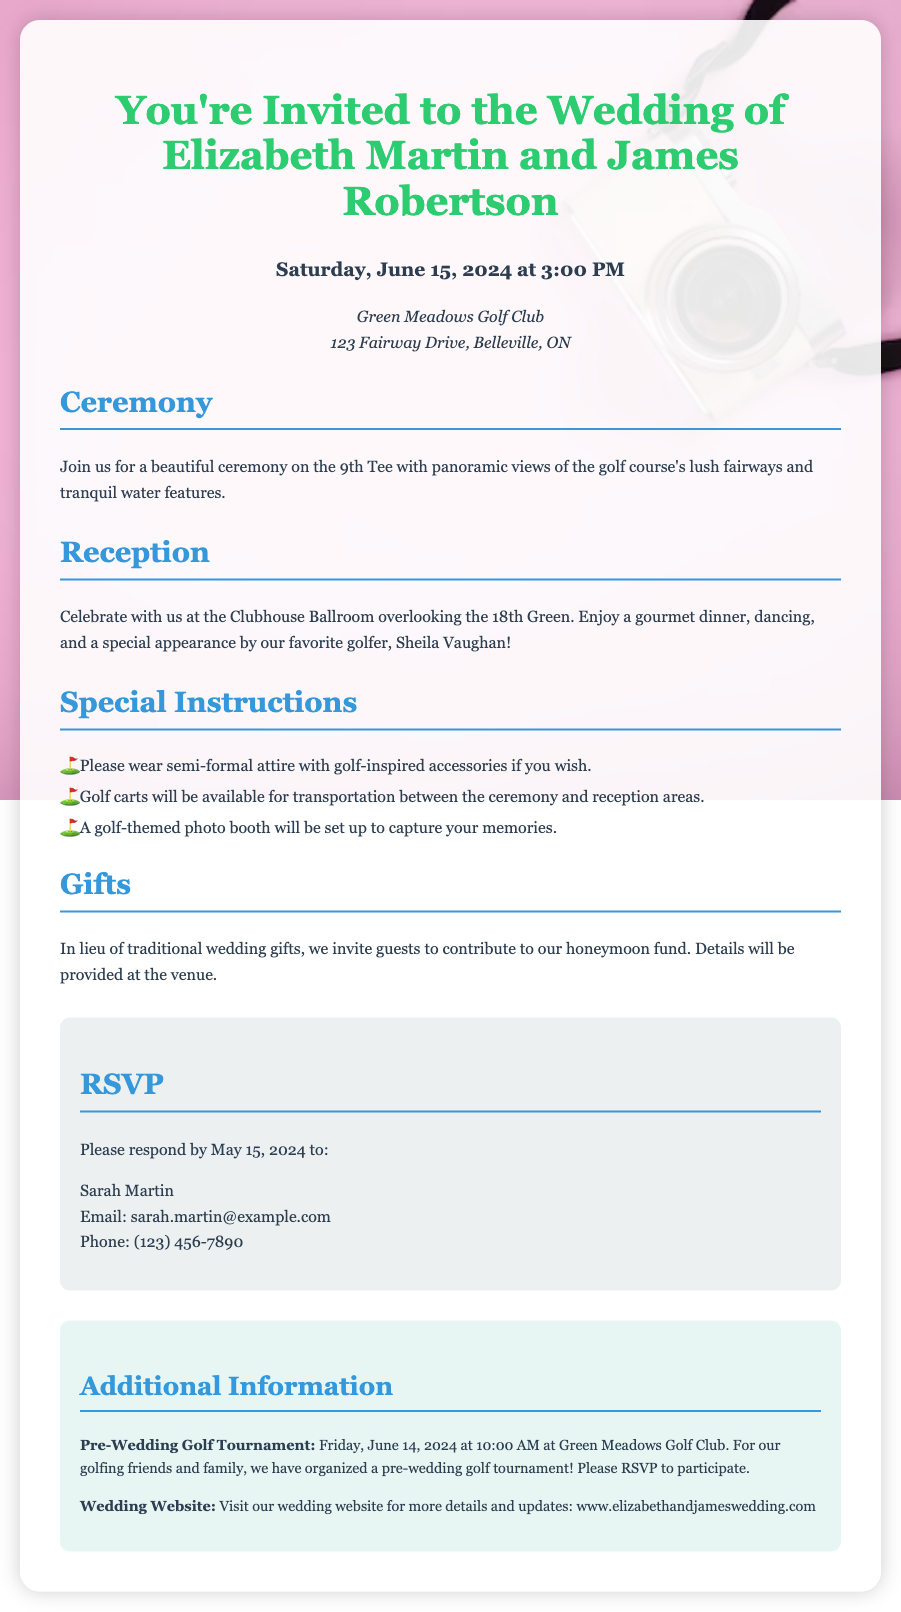What are the names of the couple? The names are stated prominently at the top of the invitation.
Answer: Elizabeth Martin and James Robertson When is the wedding date? The date is specified in the invitation under the date and time section.
Answer: Saturday, June 15, 2024 Where is the ceremony taking place? The location for the ceremony is mentioned in the venue section.
Answer: 9th Tee at Green Meadows Golf Club What type of attire is suggested? The suggested attire is located in the special instructions section.
Answer: Semi-formal attire What special feature is included in the reception? The special feature is stated in the reception section regarding entertainment.
Answer: Appearance by Sheila Vaughan What is the RSVP deadline? The deadline for RSVPs is clearly mentioned in the RSVP section.
Answer: May 15, 2024 Is there a pre-wedding event? The invitation mentions a pre-wedding event and its date.
Answer: Pre-Wedding Golf Tournament What should guests contribute to instead of gifts? This information is provided in the gifts section of the invitation.
Answer: Honeymoon fund How can guests confirm their attendance? The RSVP section outlines how guests can respond.
Answer: Email or Phone 